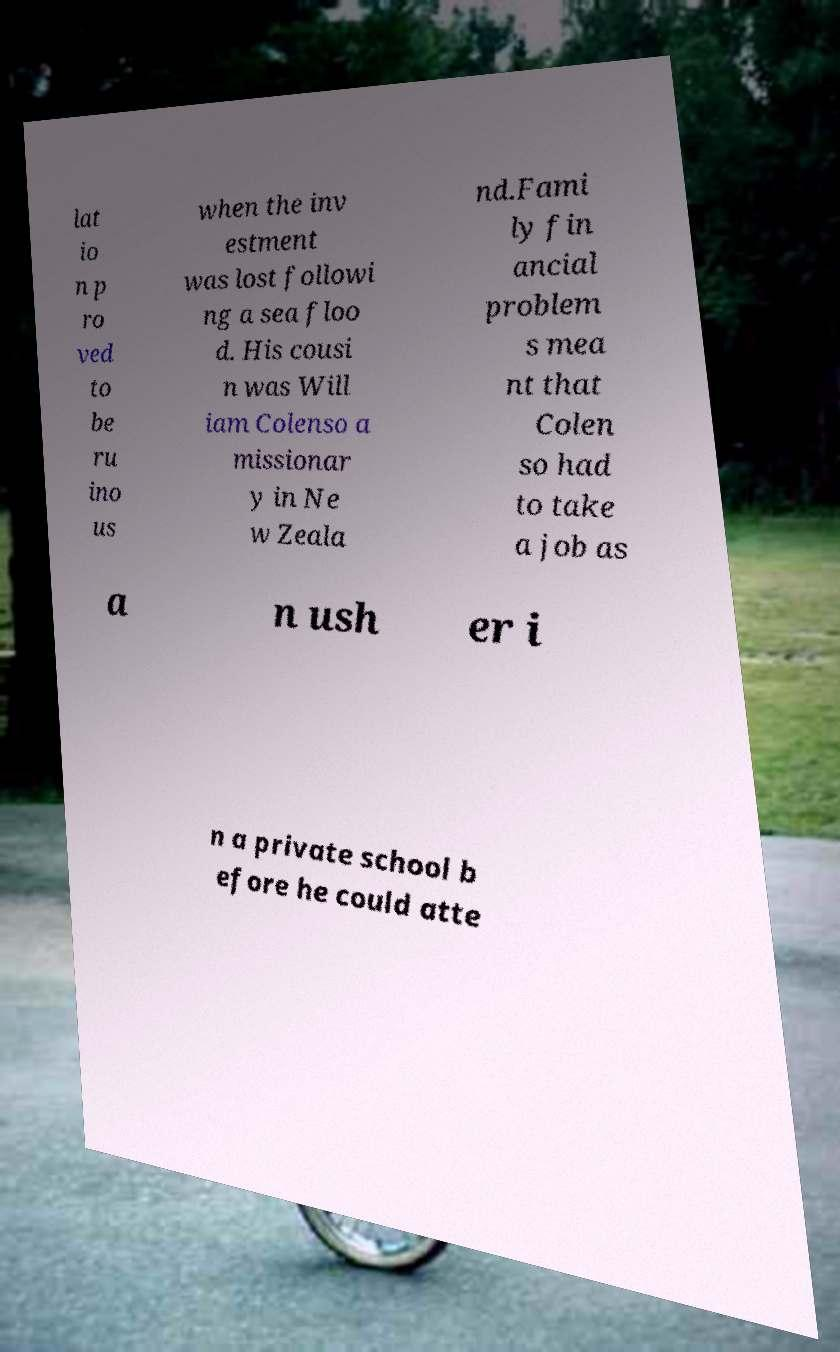Please identify and transcribe the text found in this image. lat io n p ro ved to be ru ino us when the inv estment was lost followi ng a sea floo d. His cousi n was Will iam Colenso a missionar y in Ne w Zeala nd.Fami ly fin ancial problem s mea nt that Colen so had to take a job as a n ush er i n a private school b efore he could atte 